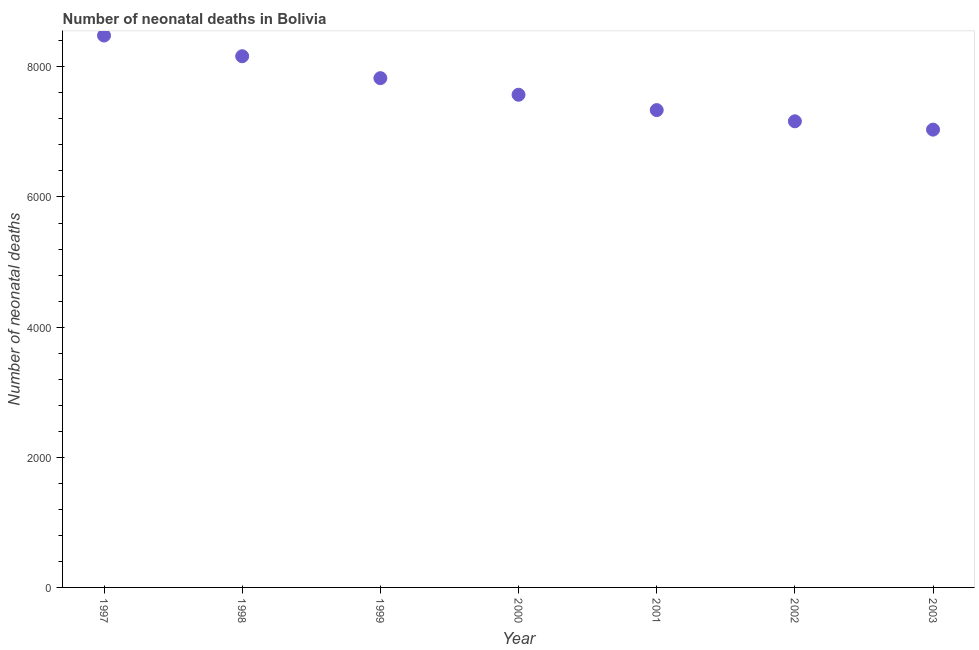What is the number of neonatal deaths in 2002?
Give a very brief answer. 7163. Across all years, what is the maximum number of neonatal deaths?
Offer a very short reply. 8481. Across all years, what is the minimum number of neonatal deaths?
Offer a terse response. 7035. In which year was the number of neonatal deaths maximum?
Offer a terse response. 1997. What is the sum of the number of neonatal deaths?
Give a very brief answer. 5.36e+04. What is the difference between the number of neonatal deaths in 1998 and 2003?
Your answer should be very brief. 1128. What is the average number of neonatal deaths per year?
Offer a very short reply. 7653.43. What is the median number of neonatal deaths?
Your response must be concise. 7571. In how many years, is the number of neonatal deaths greater than 800 ?
Offer a very short reply. 7. Do a majority of the years between 1998 and 1999 (inclusive) have number of neonatal deaths greater than 4000 ?
Offer a very short reply. Yes. What is the ratio of the number of neonatal deaths in 1998 to that in 2002?
Offer a terse response. 1.14. What is the difference between the highest and the second highest number of neonatal deaths?
Provide a short and direct response. 318. Is the sum of the number of neonatal deaths in 1999 and 2001 greater than the maximum number of neonatal deaths across all years?
Offer a terse response. Yes. What is the difference between the highest and the lowest number of neonatal deaths?
Keep it short and to the point. 1446. Are the values on the major ticks of Y-axis written in scientific E-notation?
Offer a terse response. No. Does the graph contain any zero values?
Provide a short and direct response. No. Does the graph contain grids?
Provide a short and direct response. No. What is the title of the graph?
Your response must be concise. Number of neonatal deaths in Bolivia. What is the label or title of the X-axis?
Make the answer very short. Year. What is the label or title of the Y-axis?
Offer a very short reply. Number of neonatal deaths. What is the Number of neonatal deaths in 1997?
Provide a succinct answer. 8481. What is the Number of neonatal deaths in 1998?
Your response must be concise. 8163. What is the Number of neonatal deaths in 1999?
Give a very brief answer. 7826. What is the Number of neonatal deaths in 2000?
Offer a very short reply. 7571. What is the Number of neonatal deaths in 2001?
Keep it short and to the point. 7335. What is the Number of neonatal deaths in 2002?
Your response must be concise. 7163. What is the Number of neonatal deaths in 2003?
Provide a short and direct response. 7035. What is the difference between the Number of neonatal deaths in 1997 and 1998?
Make the answer very short. 318. What is the difference between the Number of neonatal deaths in 1997 and 1999?
Keep it short and to the point. 655. What is the difference between the Number of neonatal deaths in 1997 and 2000?
Offer a very short reply. 910. What is the difference between the Number of neonatal deaths in 1997 and 2001?
Provide a succinct answer. 1146. What is the difference between the Number of neonatal deaths in 1997 and 2002?
Ensure brevity in your answer.  1318. What is the difference between the Number of neonatal deaths in 1997 and 2003?
Your answer should be compact. 1446. What is the difference between the Number of neonatal deaths in 1998 and 1999?
Provide a succinct answer. 337. What is the difference between the Number of neonatal deaths in 1998 and 2000?
Your answer should be compact. 592. What is the difference between the Number of neonatal deaths in 1998 and 2001?
Make the answer very short. 828. What is the difference between the Number of neonatal deaths in 1998 and 2003?
Make the answer very short. 1128. What is the difference between the Number of neonatal deaths in 1999 and 2000?
Provide a short and direct response. 255. What is the difference between the Number of neonatal deaths in 1999 and 2001?
Your answer should be very brief. 491. What is the difference between the Number of neonatal deaths in 1999 and 2002?
Provide a succinct answer. 663. What is the difference between the Number of neonatal deaths in 1999 and 2003?
Ensure brevity in your answer.  791. What is the difference between the Number of neonatal deaths in 2000 and 2001?
Keep it short and to the point. 236. What is the difference between the Number of neonatal deaths in 2000 and 2002?
Provide a short and direct response. 408. What is the difference between the Number of neonatal deaths in 2000 and 2003?
Ensure brevity in your answer.  536. What is the difference between the Number of neonatal deaths in 2001 and 2002?
Offer a terse response. 172. What is the difference between the Number of neonatal deaths in 2001 and 2003?
Give a very brief answer. 300. What is the difference between the Number of neonatal deaths in 2002 and 2003?
Keep it short and to the point. 128. What is the ratio of the Number of neonatal deaths in 1997 to that in 1998?
Give a very brief answer. 1.04. What is the ratio of the Number of neonatal deaths in 1997 to that in 1999?
Give a very brief answer. 1.08. What is the ratio of the Number of neonatal deaths in 1997 to that in 2000?
Ensure brevity in your answer.  1.12. What is the ratio of the Number of neonatal deaths in 1997 to that in 2001?
Your answer should be very brief. 1.16. What is the ratio of the Number of neonatal deaths in 1997 to that in 2002?
Make the answer very short. 1.18. What is the ratio of the Number of neonatal deaths in 1997 to that in 2003?
Ensure brevity in your answer.  1.21. What is the ratio of the Number of neonatal deaths in 1998 to that in 1999?
Your response must be concise. 1.04. What is the ratio of the Number of neonatal deaths in 1998 to that in 2000?
Your response must be concise. 1.08. What is the ratio of the Number of neonatal deaths in 1998 to that in 2001?
Offer a terse response. 1.11. What is the ratio of the Number of neonatal deaths in 1998 to that in 2002?
Provide a succinct answer. 1.14. What is the ratio of the Number of neonatal deaths in 1998 to that in 2003?
Provide a succinct answer. 1.16. What is the ratio of the Number of neonatal deaths in 1999 to that in 2000?
Keep it short and to the point. 1.03. What is the ratio of the Number of neonatal deaths in 1999 to that in 2001?
Offer a very short reply. 1.07. What is the ratio of the Number of neonatal deaths in 1999 to that in 2002?
Your answer should be compact. 1.09. What is the ratio of the Number of neonatal deaths in 1999 to that in 2003?
Provide a short and direct response. 1.11. What is the ratio of the Number of neonatal deaths in 2000 to that in 2001?
Keep it short and to the point. 1.03. What is the ratio of the Number of neonatal deaths in 2000 to that in 2002?
Offer a terse response. 1.06. What is the ratio of the Number of neonatal deaths in 2000 to that in 2003?
Offer a very short reply. 1.08. What is the ratio of the Number of neonatal deaths in 2001 to that in 2002?
Provide a short and direct response. 1.02. What is the ratio of the Number of neonatal deaths in 2001 to that in 2003?
Give a very brief answer. 1.04. What is the ratio of the Number of neonatal deaths in 2002 to that in 2003?
Provide a short and direct response. 1.02. 